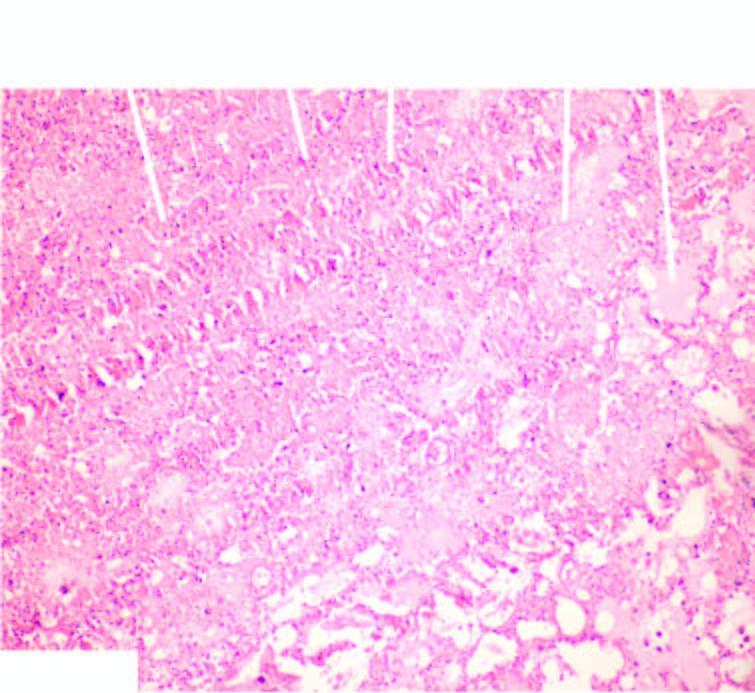what does infarcted area show?
Answer the question using a single word or phrase. Ghostal veoli filled with blood 